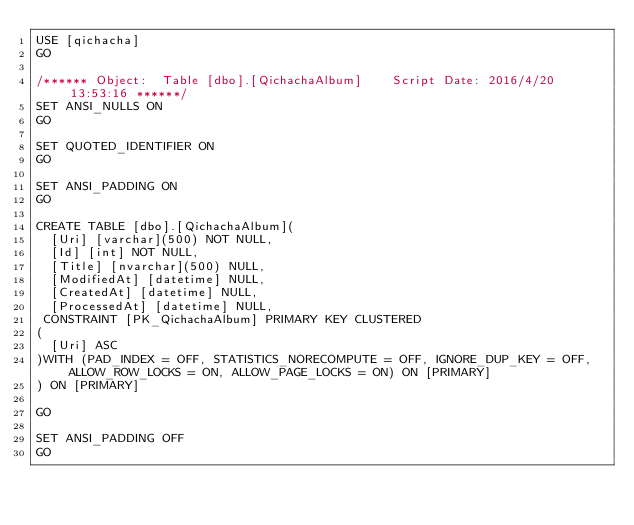Convert code to text. <code><loc_0><loc_0><loc_500><loc_500><_SQL_>USE [qichacha]
GO

/****** Object:  Table [dbo].[QichachaAlbum]    Script Date: 2016/4/20 13:53:16 ******/
SET ANSI_NULLS ON
GO

SET QUOTED_IDENTIFIER ON
GO

SET ANSI_PADDING ON
GO

CREATE TABLE [dbo].[QichachaAlbum](
	[Uri] [varchar](500) NOT NULL,
	[Id] [int] NOT NULL,
	[Title] [nvarchar](500) NULL,
	[ModifiedAt] [datetime] NULL,
	[CreatedAt] [datetime] NULL,
	[ProcessedAt] [datetime] NULL,
 CONSTRAINT [PK_QichachaAlbum] PRIMARY KEY CLUSTERED 
(
	[Uri] ASC
)WITH (PAD_INDEX = OFF, STATISTICS_NORECOMPUTE = OFF, IGNORE_DUP_KEY = OFF, ALLOW_ROW_LOCKS = ON, ALLOW_PAGE_LOCKS = ON) ON [PRIMARY]
) ON [PRIMARY]

GO

SET ANSI_PADDING OFF
GO


</code> 